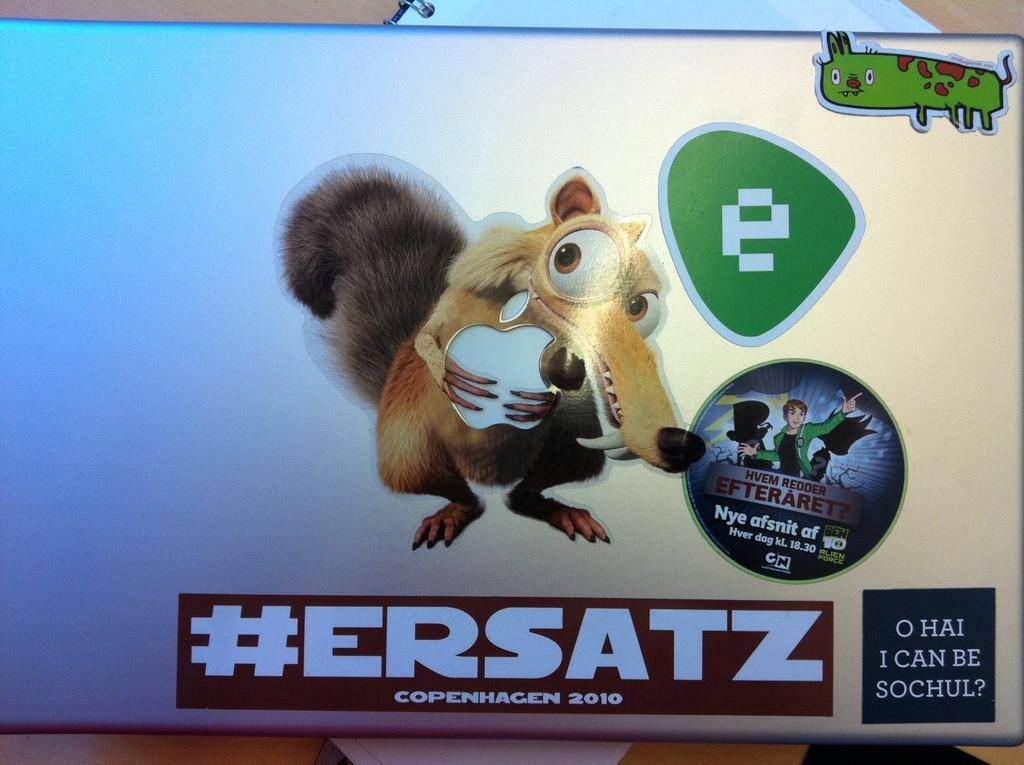What electronic device is visible in the image? There is a laptop in the image. What else is placed on the table in the image? There is a book on the table in the image. Are there any decorations or additional items on the laptop? Yes, there are stickers on the laptop. How many dogs are sitting on the laptop in the image? There are no dogs present in the image; it features a laptop with stickers and a book on a table. 